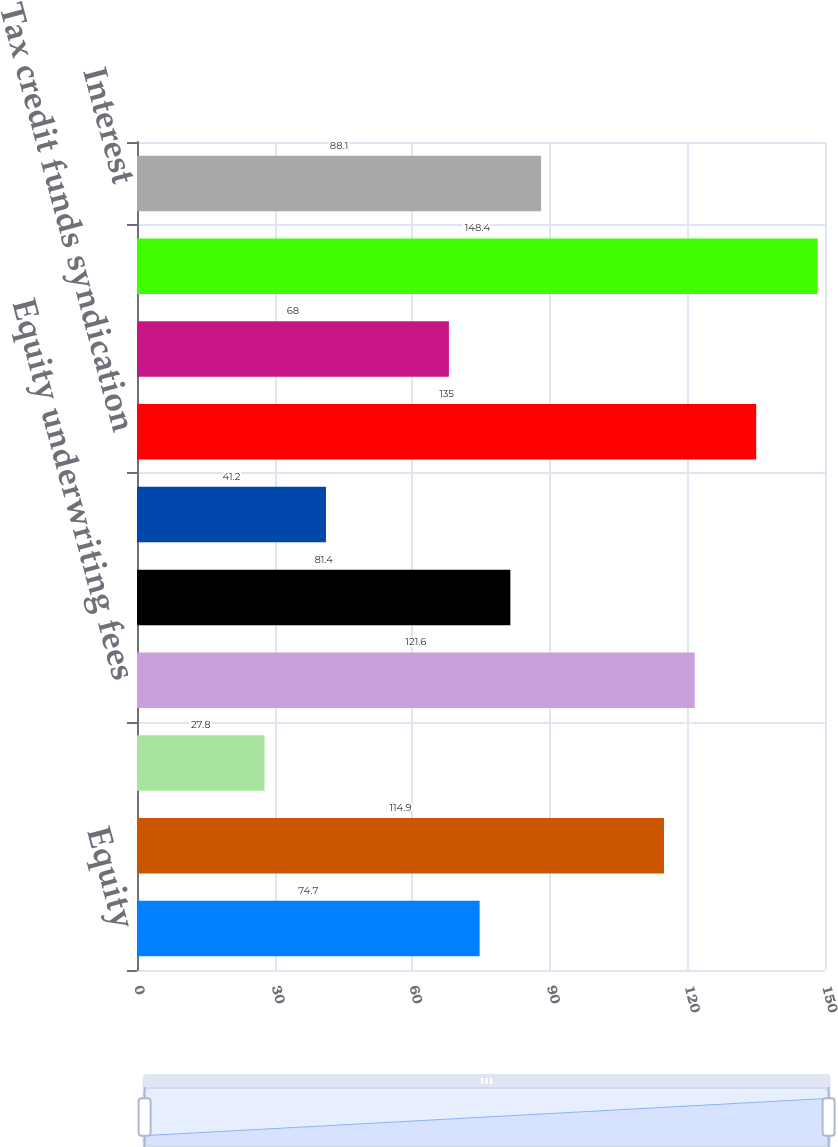<chart> <loc_0><loc_0><loc_500><loc_500><bar_chart><fcel>Equity<fcel>Fixed income<fcel>Sub-total institutional sales<fcel>Equity underwriting fees<fcel>Merger and acquisitions fees<fcel>Fixed income investment<fcel>Tax credit funds syndication<fcel>Investment advisory fees<fcel>Net trading profit<fcel>Interest<nl><fcel>74.7<fcel>114.9<fcel>27.8<fcel>121.6<fcel>81.4<fcel>41.2<fcel>135<fcel>68<fcel>148.4<fcel>88.1<nl></chart> 